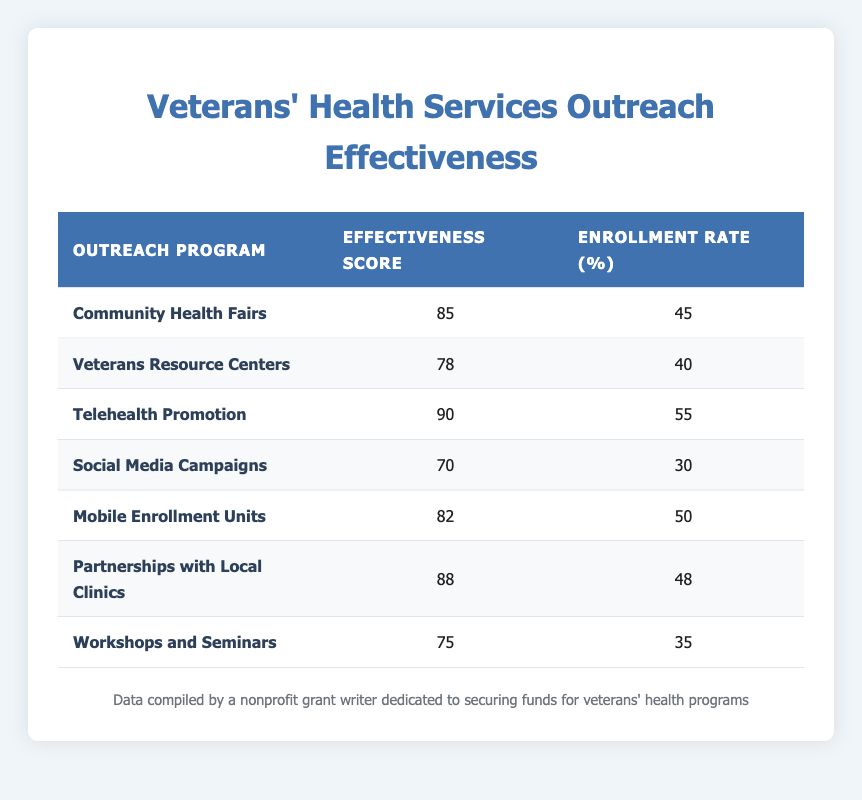What is the effectiveness score of the "Telehealth Promotion" program? The specific effectiveness score for "Telehealth Promotion" is displayed in the second column next to that program. It is listed as 90.
Answer: 90 Which outreach program has the highest enrollment rate? By examining the third column for the enrollment rates, "Telehealth Promotion" has the highest rate at 55.
Answer: Telehealth Promotion What is the average effectiveness score of all outreach programs? To find the average, sum all effectiveness scores (85 + 78 + 90 + 70 + 82 + 88 + 75 = 558). Divide by the number of programs (7) to get the average: 558 / 7 = 79.71.
Answer: 79.71 Is the "Mobile Enrollment Units" program more effective than the "Workshops and Seminars"? "Mobile Enrollment Units" has an effectiveness score of 82 while "Workshops and Seminars" has a score of 75. Since 82 is greater than 75, it is true that Mobile Enrollment Units is more effective.
Answer: Yes What is the total enrollment rate of programs with an effectiveness score above 80? Identify programs with scores above 80: "Community Health Fairs" - 45, "Telehealth Promotion" - 55, "Mobile Enrollment Units" - 50, "Partnerships with Local Clinics" - 48. The total enrollment rate is 45 + 55 + 50 + 48 = 198.
Answer: 198 How many outreach programs have an enrollment rate lower than 40%? Two programs have enrollment rates lower than 40%: "Social Media Campaigns" at 30% and "Veterans Resource Centers" at 40%, making a total of 1 program below 40%.
Answer: 1 Which outreach program has the lowest effectiveness score and what is it? The lowest effectiveness score can be found by reviewing each program's score. "Social Media Campaigns" has the lowest score of 70.
Answer: Social Media Campaigns, 70 What is the difference in enrollment rates between the most and least effective outreach program? The most effective program with the highest score is "Telehealth Promotion" at 90, enrolling 55, while the least effective is "Social Media Campaigns" at 70, enrolling 30. The difference in enrollment rates is 55 - 30 = 25.
Answer: 25 